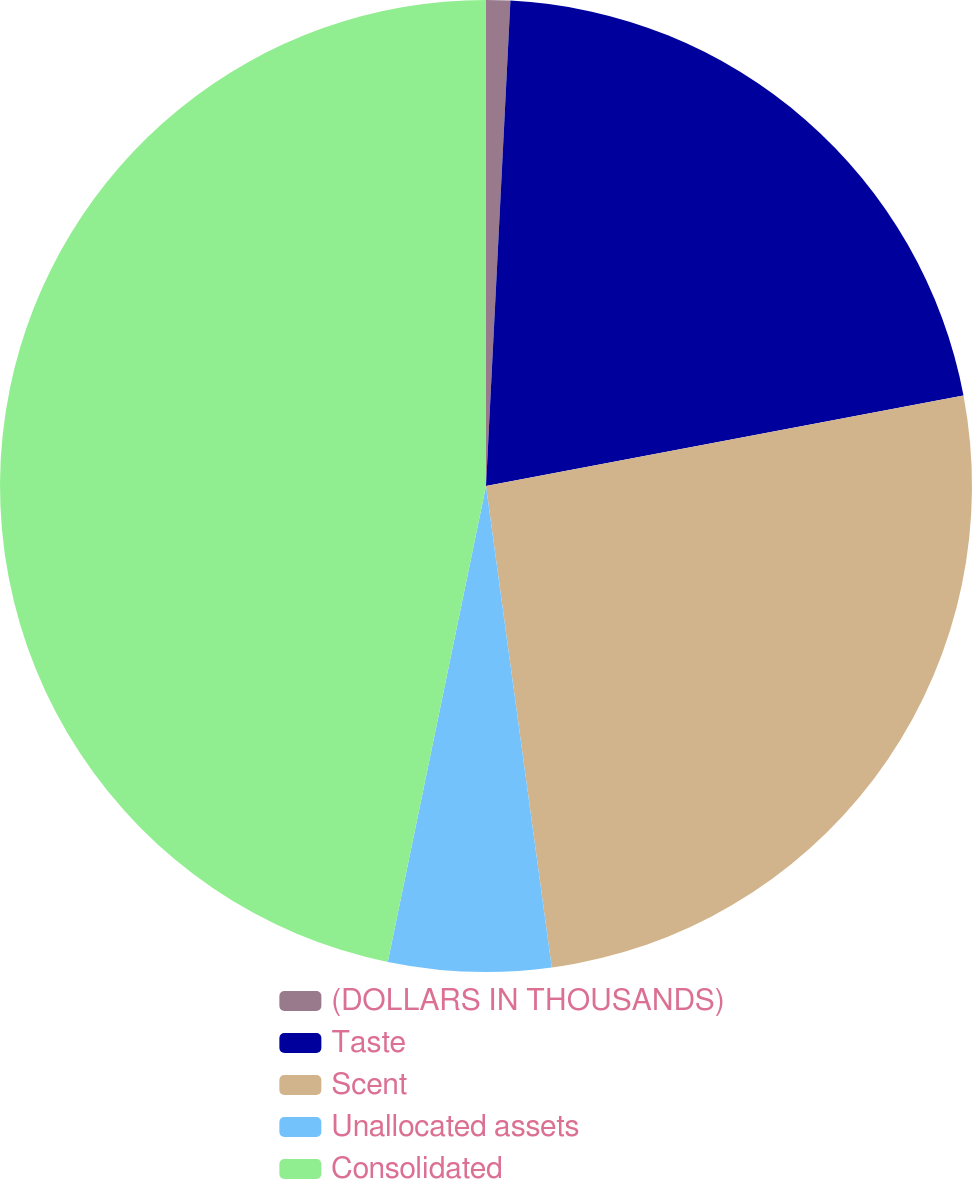Convert chart. <chart><loc_0><loc_0><loc_500><loc_500><pie_chart><fcel>(DOLLARS IN THOUSANDS)<fcel>Taste<fcel>Scent<fcel>Unallocated assets<fcel>Consolidated<nl><fcel>0.8%<fcel>21.22%<fcel>25.82%<fcel>5.4%<fcel>46.76%<nl></chart> 